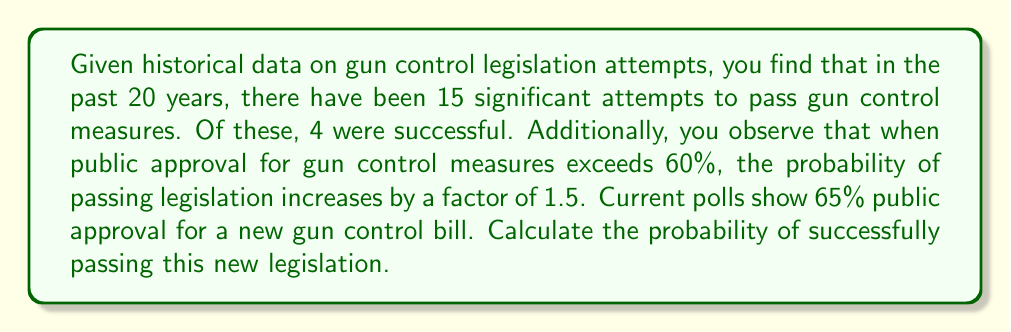Solve this math problem. Let's approach this problem step-by-step:

1) First, let's calculate the base probability of success without considering the current public approval:

   $$P(\text{success}) = \frac{\text{number of successful attempts}}{\text{total number of attempts}} = \frac{4}{15} \approx 0.2667$$

2) Now, we need to adjust this probability based on the current public approval. We're told that when public approval exceeds 60%, the probability increases by a factor of 1.5.

3) The current public approval is 65%, which does exceed 60%. Therefore, we need to multiply our base probability by 1.5:

   $$P(\text{success with high approval}) = P(\text{success}) \times 1.5$$
   
   $$P(\text{success with high approval}) = 0.2667 \times 1.5 = 0.4$$

4) To express this as a percentage:

   $$0.4 \times 100\% = 40\%$$

Therefore, given the historical data and the current high public approval, the probability of successfully passing the new gun control legislation is 40%.
Answer: 40% 